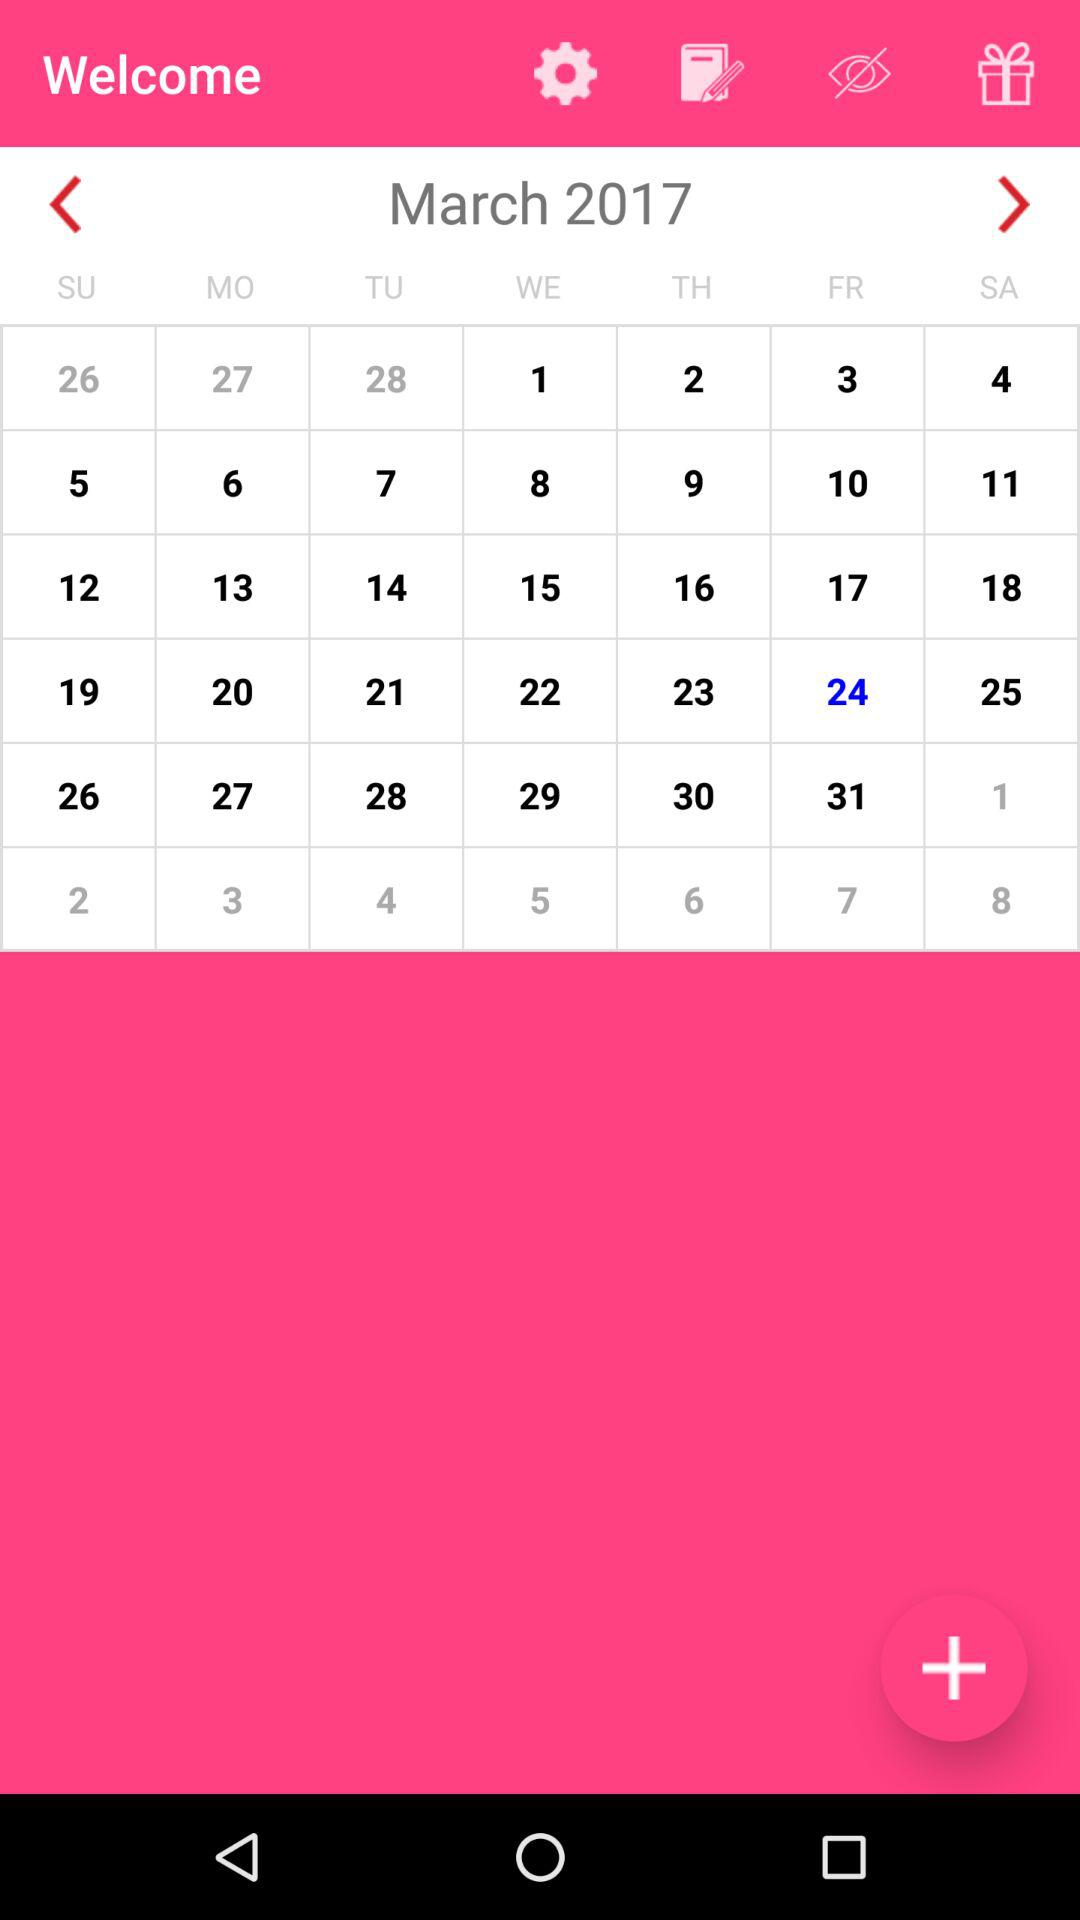Which date is selected? The selected date is Friday, March 24, 2017. 